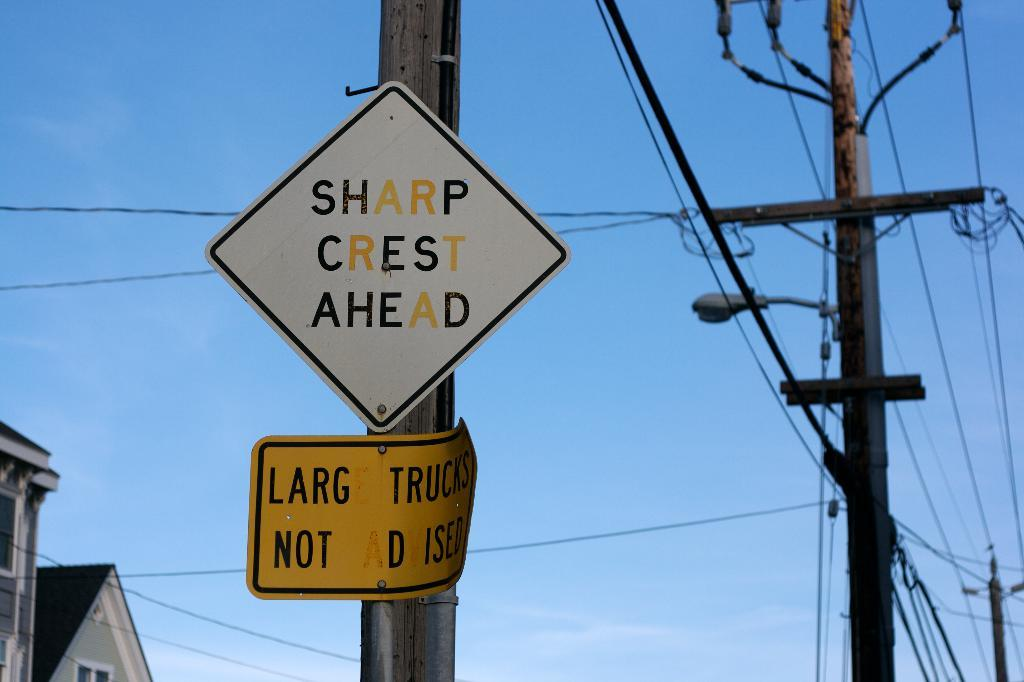<image>
Share a concise interpretation of the image provided. Sharp crest ahead sign is on a pole 